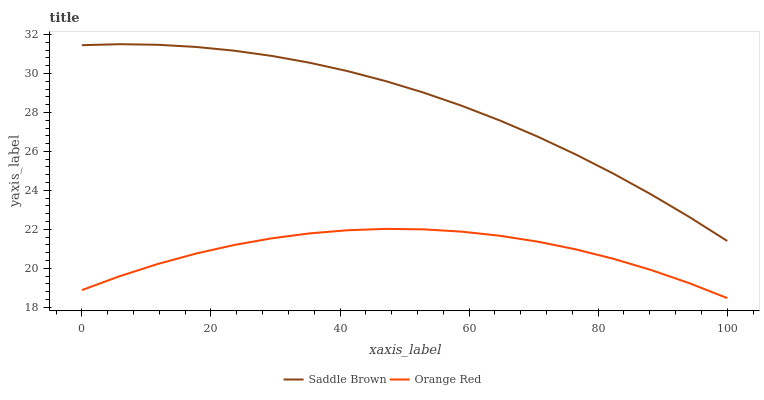Does Orange Red have the minimum area under the curve?
Answer yes or no. Yes. Does Saddle Brown have the maximum area under the curve?
Answer yes or no. Yes. Does Orange Red have the maximum area under the curve?
Answer yes or no. No. Is Saddle Brown the smoothest?
Answer yes or no. Yes. Is Orange Red the roughest?
Answer yes or no. Yes. Is Orange Red the smoothest?
Answer yes or no. No. Does Saddle Brown have the highest value?
Answer yes or no. Yes. Does Orange Red have the highest value?
Answer yes or no. No. Is Orange Red less than Saddle Brown?
Answer yes or no. Yes. Is Saddle Brown greater than Orange Red?
Answer yes or no. Yes. Does Orange Red intersect Saddle Brown?
Answer yes or no. No. 